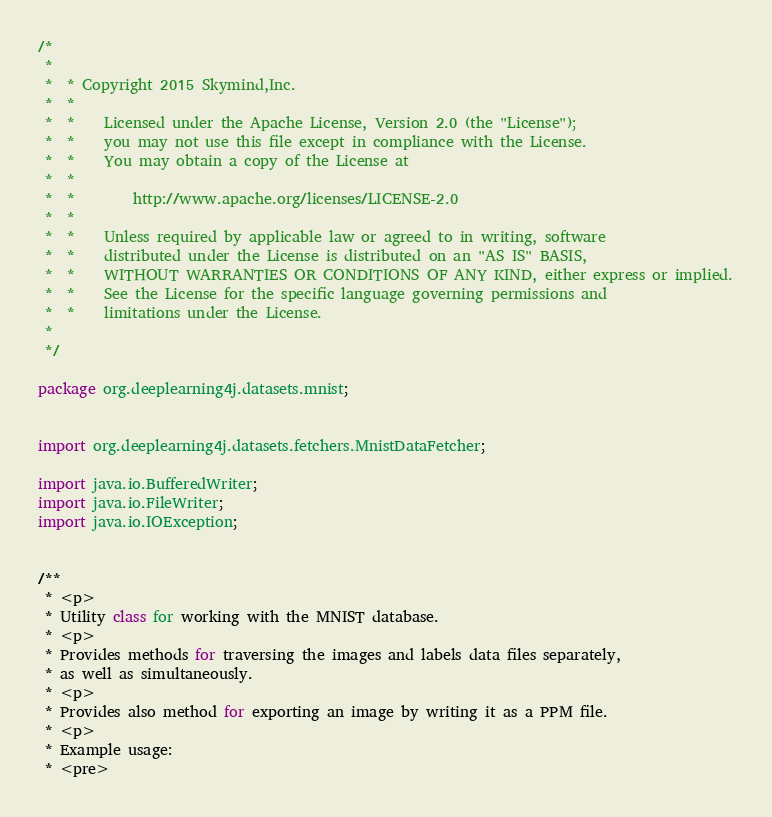<code> <loc_0><loc_0><loc_500><loc_500><_Java_>/*
 *
 *  * Copyright 2015 Skymind,Inc.
 *  *
 *  *    Licensed under the Apache License, Version 2.0 (the "License");
 *  *    you may not use this file except in compliance with the License.
 *  *    You may obtain a copy of the License at
 *  *
 *  *        http://www.apache.org/licenses/LICENSE-2.0
 *  *
 *  *    Unless required by applicable law or agreed to in writing, software
 *  *    distributed under the License is distributed on an "AS IS" BASIS,
 *  *    WITHOUT WARRANTIES OR CONDITIONS OF ANY KIND, either express or implied.
 *  *    See the License for the specific language governing permissions and
 *  *    limitations under the License.
 *
 */

package org.deeplearning4j.datasets.mnist;


import org.deeplearning4j.datasets.fetchers.MnistDataFetcher;

import java.io.BufferedWriter;
import java.io.FileWriter;
import java.io.IOException;


/**
 * <p>
 * Utility class for working with the MNIST database.
 * <p>
 * Provides methods for traversing the images and labels data files separately,
 * as well as simultaneously.
 * <p>
 * Provides also method for exporting an image by writing it as a PPM file.
 * <p> 
 * Example usage:
 * <pre></code> 